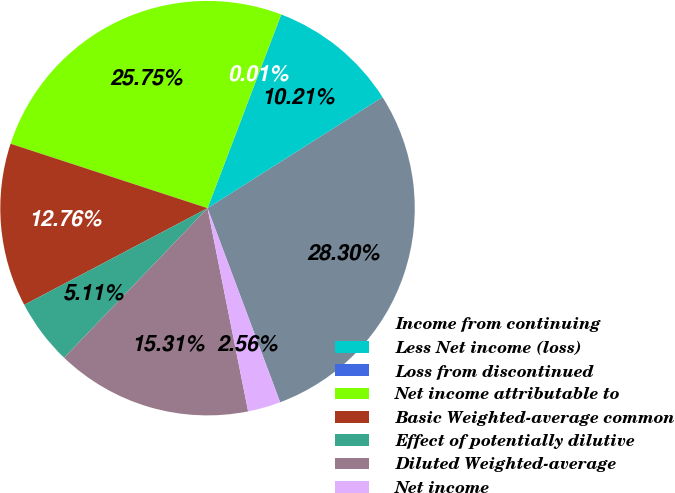<chart> <loc_0><loc_0><loc_500><loc_500><pie_chart><fcel>Income from continuing<fcel>Less Net income (loss)<fcel>Loss from discontinued<fcel>Net income attributable to<fcel>Basic Weighted-average common<fcel>Effect of potentially dilutive<fcel>Diluted Weighted-average<fcel>Net income<nl><fcel>28.31%<fcel>10.21%<fcel>0.01%<fcel>25.76%<fcel>12.76%<fcel>5.11%<fcel>15.31%<fcel>2.56%<nl></chart> 